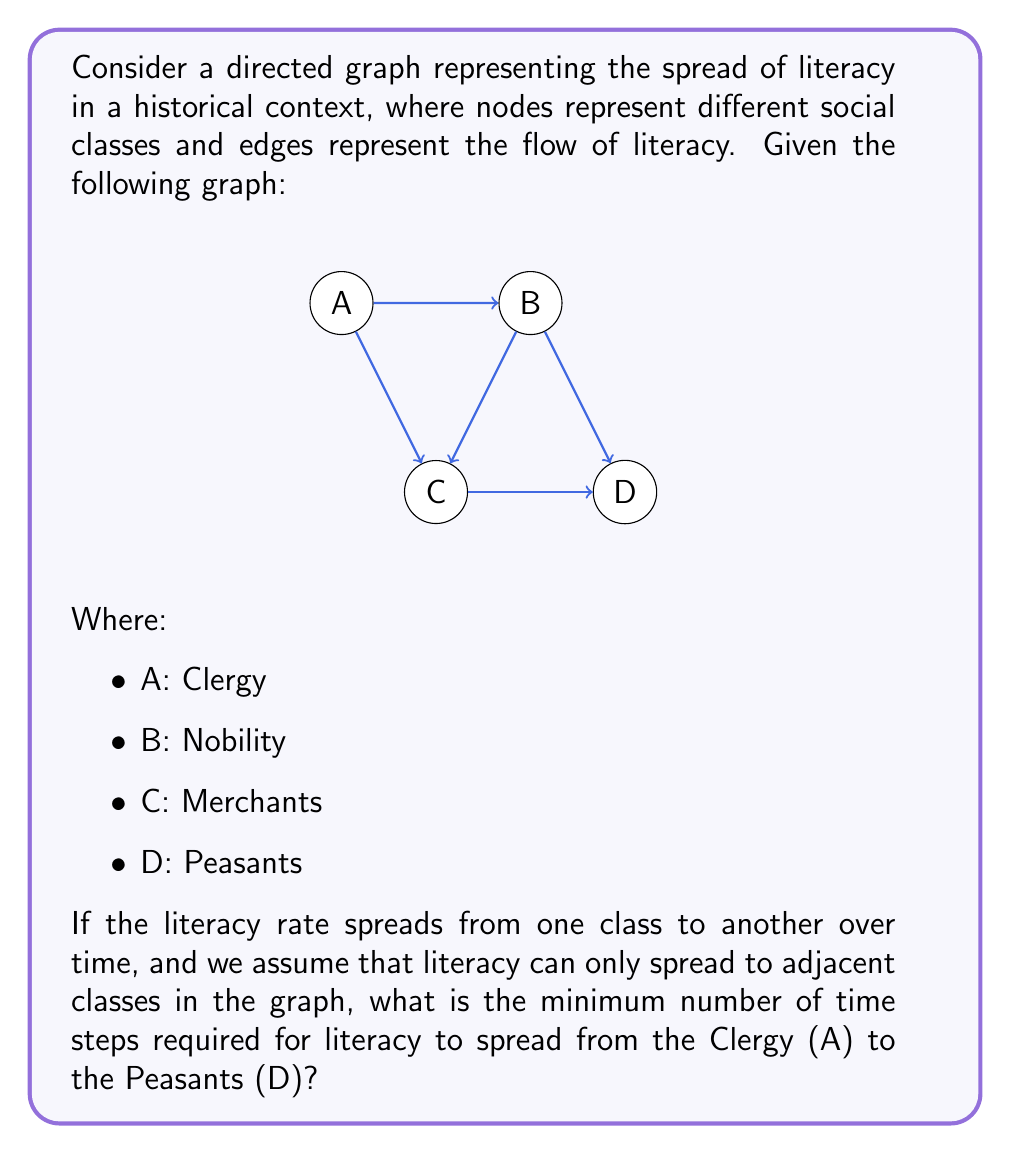Can you answer this question? To solve this problem, we need to find the shortest path from node A (Clergy) to node D (Peasants) in the directed graph. This can be done using a breadth-first search (BFS) algorithm or by manually tracing the paths.

Let's trace the paths:

1. Start at node A (Clergy)
2. From A, we can reach:
   - B (Nobility) in 1 step
   - C (Merchants) in 1 step
3. From B, we can reach:
   - C (Merchants) in 1 step (total 2 steps from A)
   - D (Peasants) in 1 step (total 2 steps from A)
4. From C, we can reach:
   - D (Peasants) in 1 step (total 2 steps from A if reached directly, or 3 steps if reached through B)

The shortest path from A to D is:
A → B → D

This path takes 2 time steps.

Historically, this could represent the spread of literacy from the Clergy to the Nobility, and then from the Nobility to the Peasants. This model simplifies the complex historical process of literacy spread but provides a framework for understanding the general flow of knowledge and skills through different social classes.
Answer: The minimum number of time steps required for literacy to spread from the Clergy (A) to the Peasants (D) is 2. 